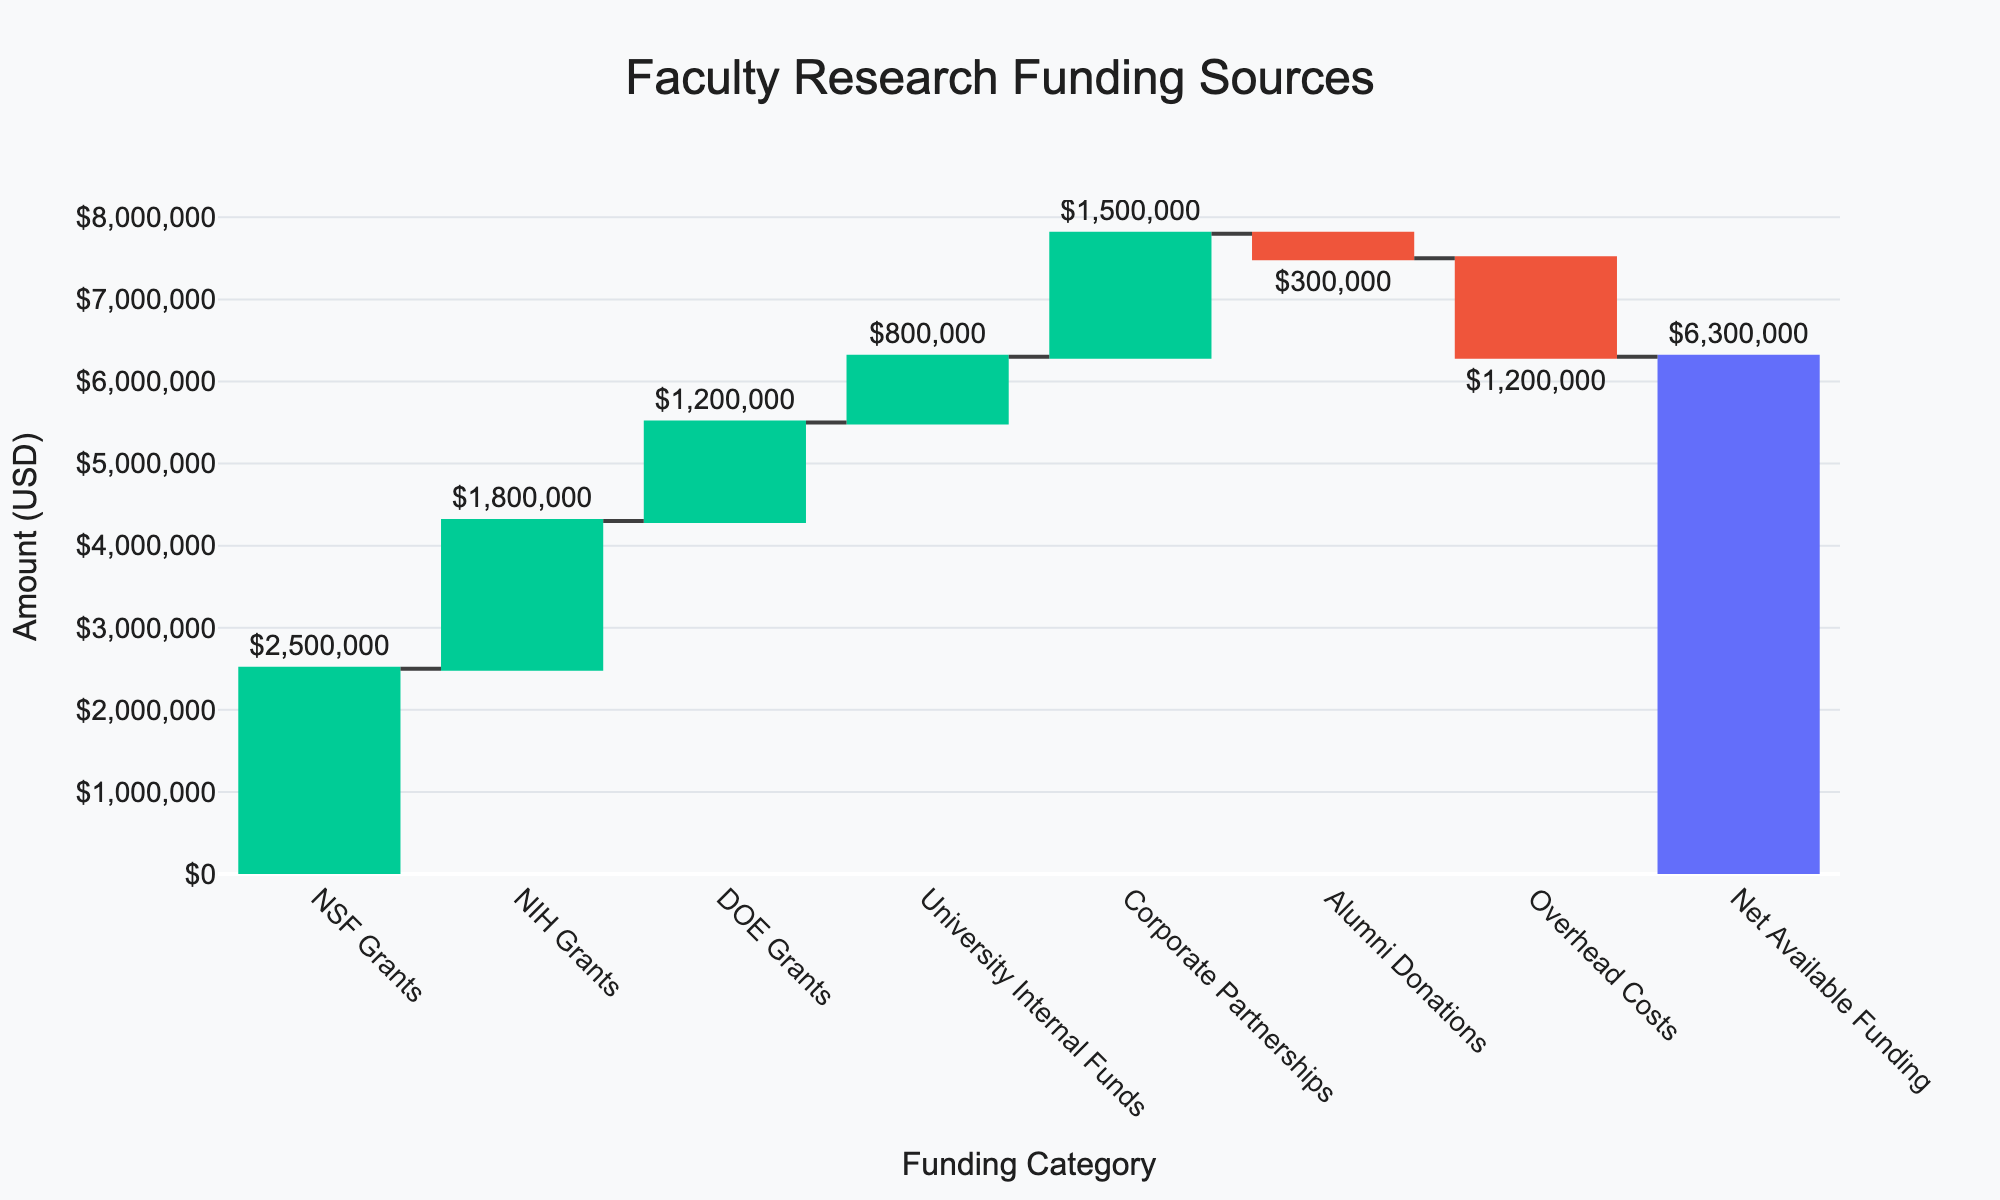what is the title of the chart? The title of the chart is prominently displayed at the top of the figure. It is written in a larger font size for easy visibility. The information can be directly read from the chart.
Answer: "Faculty Research Funding Sources" What is the total amount of NSF Grants? The total amount for NSF Grants is stated in one of the bar segments of the waterfall chart and is labeled with a text value. It is visually represented as the first increment after the initial base value.
Answer: $2,500,000 How much money comes from Alumni Donations and what is its effect on the total? Alumni Donations are shown as a segment in the waterfall chart. The value here is presented with a negative sign which indicates a reduction from the total available funding. The value is written as a negative figure.
Answer: -$300,000 What is the difference between NIH Grants and Corporate Partnerships funding? To find the difference between NIH Grants and Corporate Partnerships, locate the values for both which are positioned as individual segments in the waterfall chart. NIH Grants are valued at $1,800,000 and Corporate Partnerships at $1,500,000. Subtract the two figures. \(1,800,000 - 1,500,000\).
Answer: $300,000 What category contributes the least to the overall funding? Each category is represented as a segment in the waterfall chart. The one with the smallest absolute value is the category that contributes the least. Upon scanning, Alumni Donations have a value of $-300,000 which is the smallest among all the categories, representing a negative contribution.
Answer: Alumni Donations Which two categories are decreasing the total available funding? Categories which decrease the total funding are represented with negative values in the waterfall chart. The segments for these categories can be identified by their negative values in a different color reserved for decreasing segments in the chart. Upon inspection, Alumni Donations and Overhead Costs are the decreasing categories.
Answer: Alumni Donations and Overhead Costs What is the total contribution from government grants? The government grants are summarized by adding the individual amounts contributed by NSF Grants, NIH Grants, and DOE Grants. These amounts are found in their respective segments: \(2,500,000 + 1,800,000 + 1,200,000\). Sum these values to get the total contribution from government grants.
Answer: $5,500,000 What is the net available funding after considering all sources and deductions? The net available funding is typically the last total value shown in a waterfall chart and signifies the final value after accounting for all additions and subtractions. It is stated as the last segment in the chart.
Answer: $6,300,000 How does University Internal Funds compare to Overhead Costs in terms of value? University Internal Funds and Overhead Costs are represented as individual segments in the waterfall chart. Compare their values directly, where University Internal Funds contribute $800,000, and Overhead Costs reduce by $1,200,000. $800,000 is greater comparatively.
Answer: University Internal Funds are greater by $400,000 